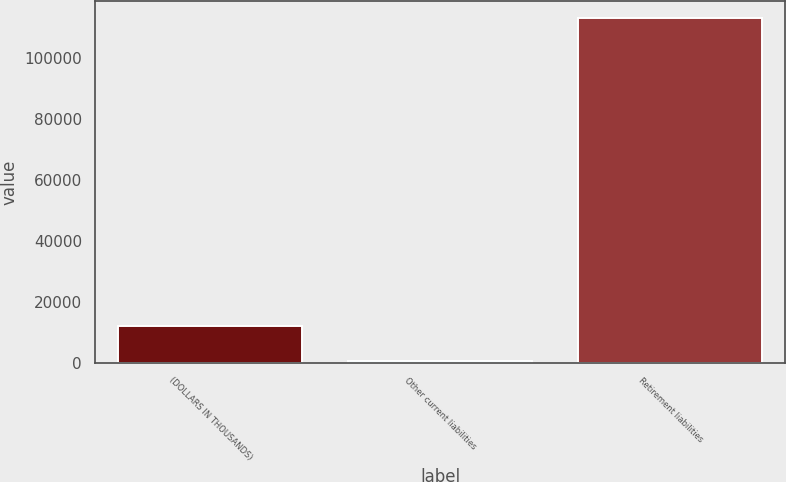Convert chart to OTSL. <chart><loc_0><loc_0><loc_500><loc_500><bar_chart><fcel>(DOLLARS IN THOUSANDS)<fcel>Other current liabilities<fcel>Retirement liabilities<nl><fcel>11857.5<fcel>608<fcel>113103<nl></chart> 